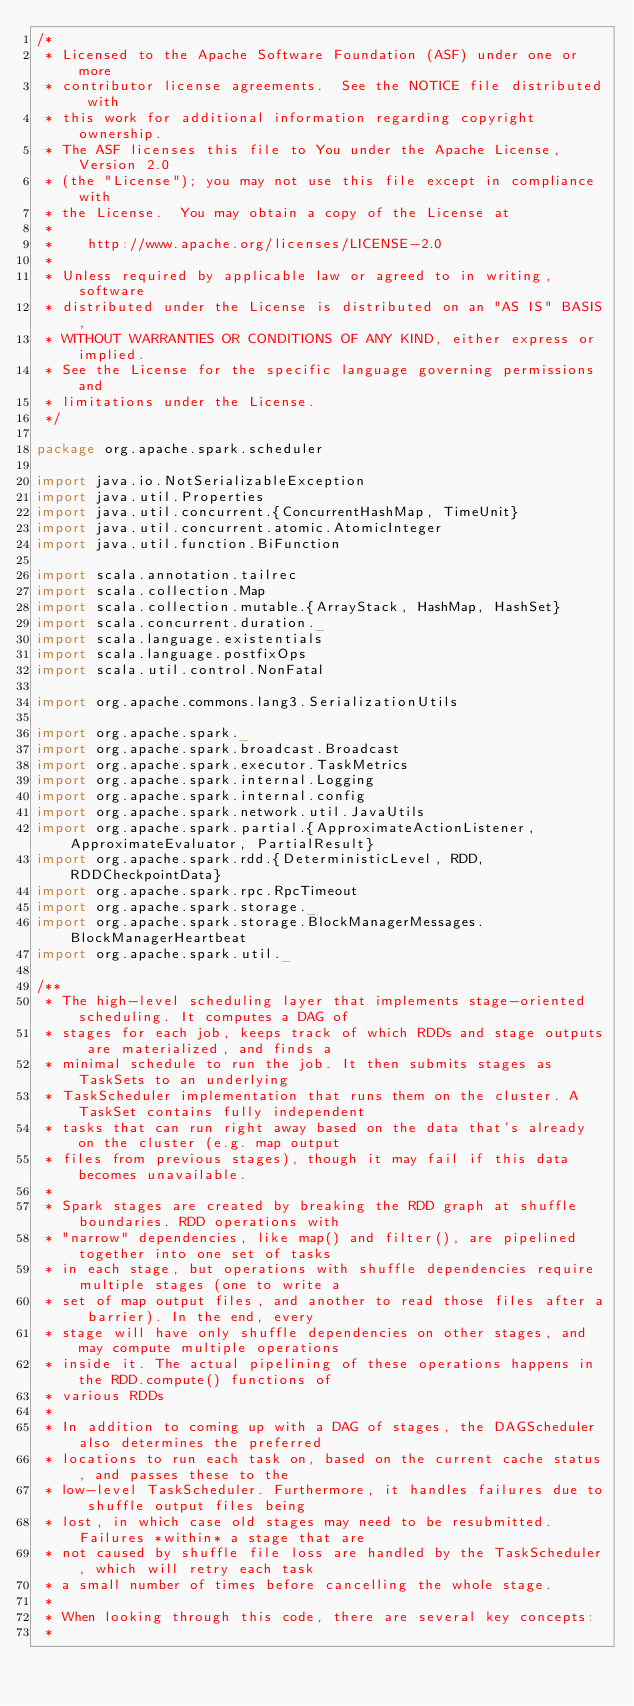Convert code to text. <code><loc_0><loc_0><loc_500><loc_500><_Scala_>/*
 * Licensed to the Apache Software Foundation (ASF) under one or more
 * contributor license agreements.  See the NOTICE file distributed with
 * this work for additional information regarding copyright ownership.
 * The ASF licenses this file to You under the Apache License, Version 2.0
 * (the "License"); you may not use this file except in compliance with
 * the License.  You may obtain a copy of the License at
 *
 *    http://www.apache.org/licenses/LICENSE-2.0
 *
 * Unless required by applicable law or agreed to in writing, software
 * distributed under the License is distributed on an "AS IS" BASIS,
 * WITHOUT WARRANTIES OR CONDITIONS OF ANY KIND, either express or implied.
 * See the License for the specific language governing permissions and
 * limitations under the License.
 */

package org.apache.spark.scheduler

import java.io.NotSerializableException
import java.util.Properties
import java.util.concurrent.{ConcurrentHashMap, TimeUnit}
import java.util.concurrent.atomic.AtomicInteger
import java.util.function.BiFunction

import scala.annotation.tailrec
import scala.collection.Map
import scala.collection.mutable.{ArrayStack, HashMap, HashSet}
import scala.concurrent.duration._
import scala.language.existentials
import scala.language.postfixOps
import scala.util.control.NonFatal

import org.apache.commons.lang3.SerializationUtils

import org.apache.spark._
import org.apache.spark.broadcast.Broadcast
import org.apache.spark.executor.TaskMetrics
import org.apache.spark.internal.Logging
import org.apache.spark.internal.config
import org.apache.spark.network.util.JavaUtils
import org.apache.spark.partial.{ApproximateActionListener, ApproximateEvaluator, PartialResult}
import org.apache.spark.rdd.{DeterministicLevel, RDD, RDDCheckpointData}
import org.apache.spark.rpc.RpcTimeout
import org.apache.spark.storage._
import org.apache.spark.storage.BlockManagerMessages.BlockManagerHeartbeat
import org.apache.spark.util._

/**
 * The high-level scheduling layer that implements stage-oriented scheduling. It computes a DAG of
 * stages for each job, keeps track of which RDDs and stage outputs are materialized, and finds a
 * minimal schedule to run the job. It then submits stages as TaskSets to an underlying
 * TaskScheduler implementation that runs them on the cluster. A TaskSet contains fully independent
 * tasks that can run right away based on the data that's already on the cluster (e.g. map output
 * files from previous stages), though it may fail if this data becomes unavailable.
 *
 * Spark stages are created by breaking the RDD graph at shuffle boundaries. RDD operations with
 * "narrow" dependencies, like map() and filter(), are pipelined together into one set of tasks
 * in each stage, but operations with shuffle dependencies require multiple stages (one to write a
 * set of map output files, and another to read those files after a barrier). In the end, every
 * stage will have only shuffle dependencies on other stages, and may compute multiple operations
 * inside it. The actual pipelining of these operations happens in the RDD.compute() functions of
 * various RDDs
 *
 * In addition to coming up with a DAG of stages, the DAGScheduler also determines the preferred
 * locations to run each task on, based on the current cache status, and passes these to the
 * low-level TaskScheduler. Furthermore, it handles failures due to shuffle output files being
 * lost, in which case old stages may need to be resubmitted. Failures *within* a stage that are
 * not caused by shuffle file loss are handled by the TaskScheduler, which will retry each task
 * a small number of times before cancelling the whole stage.
 *
 * When looking through this code, there are several key concepts:
 *</code> 